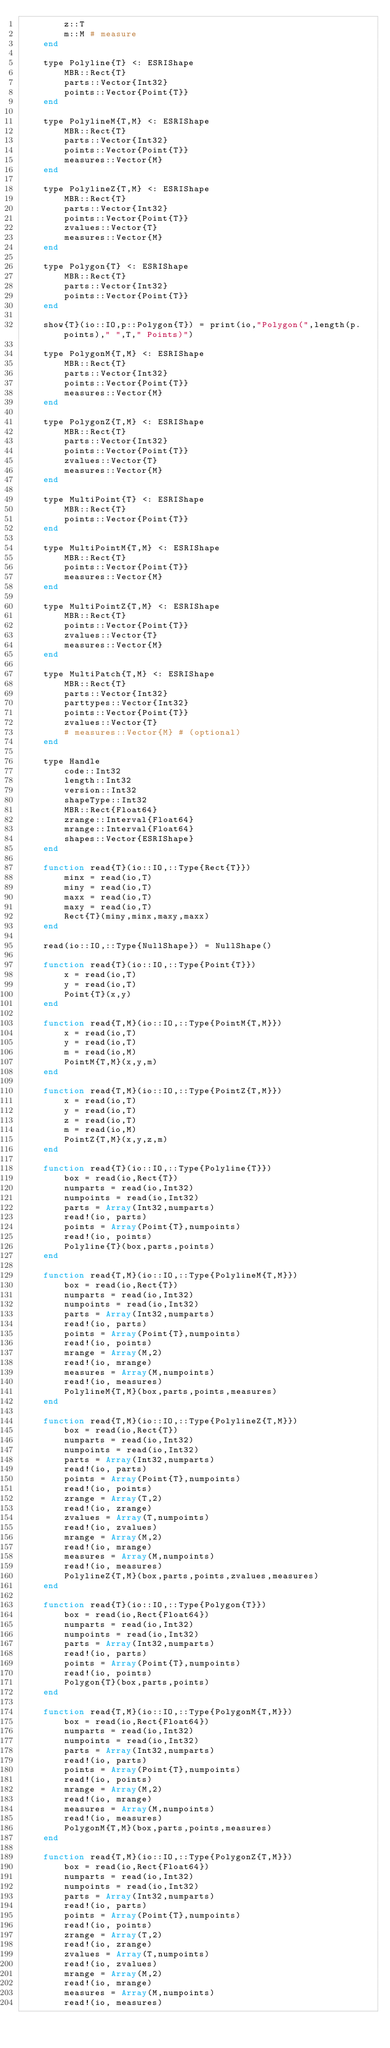<code> <loc_0><loc_0><loc_500><loc_500><_Julia_>        z::T
        m::M # measure
    end

    type Polyline{T} <: ESRIShape
        MBR::Rect{T}
        parts::Vector{Int32}
        points::Vector{Point{T}}
    end

    type PolylineM{T,M} <: ESRIShape
        MBR::Rect{T}
        parts::Vector{Int32}
        points::Vector{Point{T}}
        measures::Vector{M}
    end

    type PolylineZ{T,M} <: ESRIShape
        MBR::Rect{T}
        parts::Vector{Int32}
        points::Vector{Point{T}}
        zvalues::Vector{T}
        measures::Vector{M}
    end

    type Polygon{T} <: ESRIShape
        MBR::Rect{T}
        parts::Vector{Int32}
        points::Vector{Point{T}}
    end

    show{T}(io::IO,p::Polygon{T}) = print(io,"Polygon(",length(p.points)," ",T," Points)")

    type PolygonM{T,M} <: ESRIShape
        MBR::Rect{T}
        parts::Vector{Int32}
        points::Vector{Point{T}}
        measures::Vector{M}
    end

    type PolygonZ{T,M} <: ESRIShape
        MBR::Rect{T}
        parts::Vector{Int32}
        points::Vector{Point{T}}
        zvalues::Vector{T}
        measures::Vector{M}
    end

    type MultiPoint{T} <: ESRIShape
        MBR::Rect{T}
        points::Vector{Point{T}}
    end

    type MultiPointM{T,M} <: ESRIShape
        MBR::Rect{T}
        points::Vector{Point{T}}
        measures::Vector{M}
    end

    type MultiPointZ{T,M} <: ESRIShape
        MBR::Rect{T}
        points::Vector{Point{T}}
        zvalues::Vector{T}
        measures::Vector{M}
    end

    type MultiPatch{T,M} <: ESRIShape
        MBR::Rect{T}
        parts::Vector{Int32}
        parttypes::Vector{Int32}
        points::Vector{Point{T}}
        zvalues::Vector{T}
        # measures::Vector{M} # (optional)
    end

    type Handle
        code::Int32
        length::Int32
        version::Int32
        shapeType::Int32
        MBR::Rect{Float64}
        zrange::Interval{Float64}
        mrange::Interval{Float64}
        shapes::Vector{ESRIShape}
    end

    function read{T}(io::IO,::Type{Rect{T}})
        minx = read(io,T)
        miny = read(io,T)
        maxx = read(io,T)
        maxy = read(io,T)
        Rect{T}(miny,minx,maxy,maxx)
    end

    read(io::IO,::Type{NullShape}) = NullShape()

    function read{T}(io::IO,::Type{Point{T}})
        x = read(io,T)
        y = read(io,T)
        Point{T}(x,y)
    end

    function read{T,M}(io::IO,::Type{PointM{T,M}})
        x = read(io,T)
        y = read(io,T)
        m = read(io,M)
        PointM{T,M}(x,y,m)
    end

    function read{T,M}(io::IO,::Type{PointZ{T,M}})
        x = read(io,T)
        y = read(io,T)
        z = read(io,T)
        m = read(io,M)
        PointZ{T,M}(x,y,z,m)
    end

    function read{T}(io::IO,::Type{Polyline{T}})
        box = read(io,Rect{T})
        numparts = read(io,Int32)
        numpoints = read(io,Int32)
        parts = Array(Int32,numparts)
        read!(io, parts)
        points = Array(Point{T},numpoints)
        read!(io, points)
        Polyline{T}(box,parts,points)
    end

    function read{T,M}(io::IO,::Type{PolylineM{T,M}})
        box = read(io,Rect{T})
        numparts = read(io,Int32)
        numpoints = read(io,Int32)
        parts = Array(Int32,numparts)
        read!(io, parts)
        points = Array(Point{T},numpoints)
        read!(io, points)
        mrange = Array(M,2)
        read!(io, mrange)
        measures = Array(M,numpoints)
        read!(io, measures)
        PolylineM{T,M}(box,parts,points,measures)
    end

    function read{T,M}(io::IO,::Type{PolylineZ{T,M}})
        box = read(io,Rect{T})
        numparts = read(io,Int32)
        numpoints = read(io,Int32)
        parts = Array(Int32,numparts)
        read!(io, parts)
        points = Array(Point{T},numpoints)
        read!(io, points)
        zrange = Array(T,2)
        read!(io, zrange)
        zvalues = Array(T,numpoints)
        read!(io, zvalues)
        mrange = Array(M,2)
        read!(io, mrange)
        measures = Array(M,numpoints)
        read!(io, measures)
        PolylineZ{T,M}(box,parts,points,zvalues,measures)
    end

    function read{T}(io::IO,::Type{Polygon{T}})
        box = read(io,Rect{Float64})
        numparts = read(io,Int32)
        numpoints = read(io,Int32)
        parts = Array(Int32,numparts)
        read!(io, parts)
        points = Array(Point{T},numpoints)
        read!(io, points)
        Polygon{T}(box,parts,points)
    end

    function read{T,M}(io::IO,::Type{PolygonM{T,M}})
        box = read(io,Rect{Float64})
        numparts = read(io,Int32)
        numpoints = read(io,Int32)
        parts = Array(Int32,numparts)
        read!(io, parts)
        points = Array(Point{T},numpoints)
        read!(io, points)
        mrange = Array(M,2)
        read!(io, mrange)
        measures = Array(M,numpoints)
        read!(io, measures)
        PolygonM{T,M}(box,parts,points,measures)
    end

    function read{T,M}(io::IO,::Type{PolygonZ{T,M}})
        box = read(io,Rect{Float64})
        numparts = read(io,Int32)
        numpoints = read(io,Int32)
        parts = Array(Int32,numparts)
        read!(io, parts)
        points = Array(Point{T},numpoints)
        read!(io, points)
        zrange = Array(T,2)
        read!(io, zrange)
        zvalues = Array(T,numpoints)
        read!(io, zvalues)
        mrange = Array(M,2)
        read!(io, mrange)
        measures = Array(M,numpoints)
        read!(io, measures)</code> 